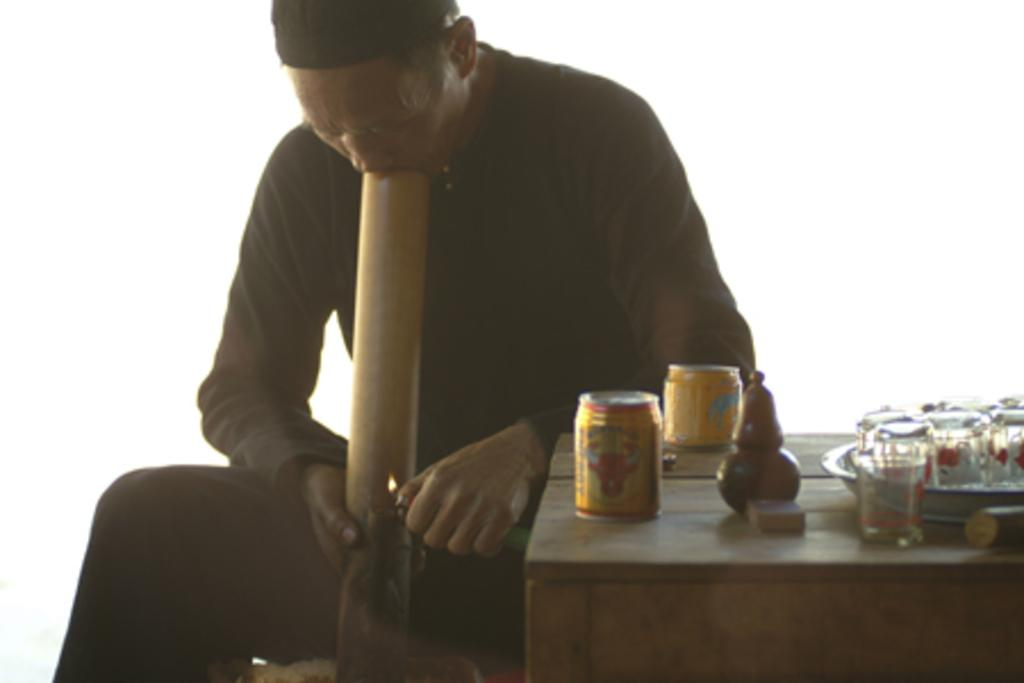What is the main subject of the image? The main subject of the image is a man. What object is also present in the image? There is a table in the image. Can you describe what is on the table? There are "few things" on the table, but the specific items are not mentioned. What is the title of the book the man is reading in the image? There is no book or mention of a book in the image, so it is not possible to determine the title. What is the man's opinion about the taste of the items on the table? There is no information about the man's opinion or the taste of the items on the table in the image. 